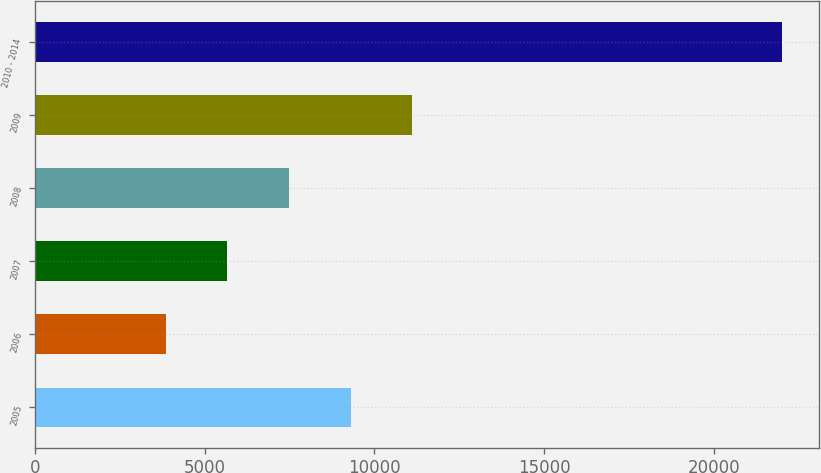Convert chart to OTSL. <chart><loc_0><loc_0><loc_500><loc_500><bar_chart><fcel>2005<fcel>2006<fcel>2007<fcel>2008<fcel>2009<fcel>2010 - 2014<nl><fcel>9297.6<fcel>3849<fcel>5665.2<fcel>7481.4<fcel>11113.8<fcel>22011<nl></chart> 